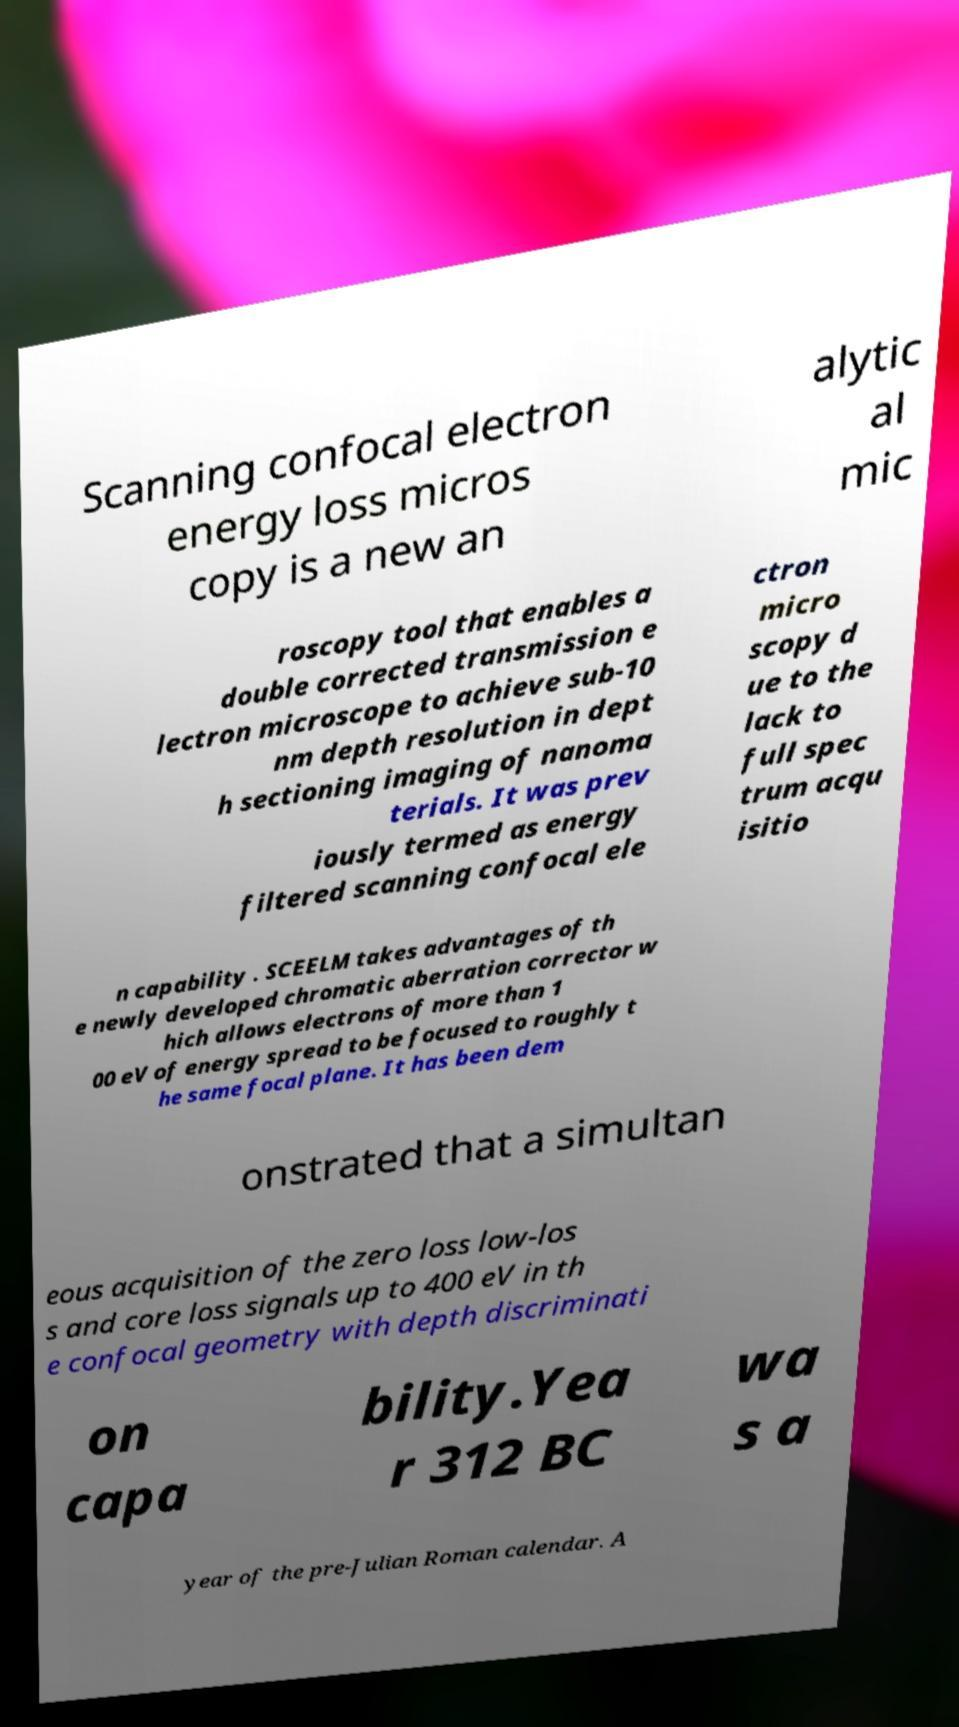Can you read and provide the text displayed in the image?This photo seems to have some interesting text. Can you extract and type it out for me? Scanning confocal electron energy loss micros copy is a new an alytic al mic roscopy tool that enables a double corrected transmission e lectron microscope to achieve sub-10 nm depth resolution in dept h sectioning imaging of nanoma terials. It was prev iously termed as energy filtered scanning confocal ele ctron micro scopy d ue to the lack to full spec trum acqu isitio n capability . SCEELM takes advantages of th e newly developed chromatic aberration corrector w hich allows electrons of more than 1 00 eV of energy spread to be focused to roughly t he same focal plane. It has been dem onstrated that a simultan eous acquisition of the zero loss low-los s and core loss signals up to 400 eV in th e confocal geometry with depth discriminati on capa bility.Yea r 312 BC wa s a year of the pre-Julian Roman calendar. A 